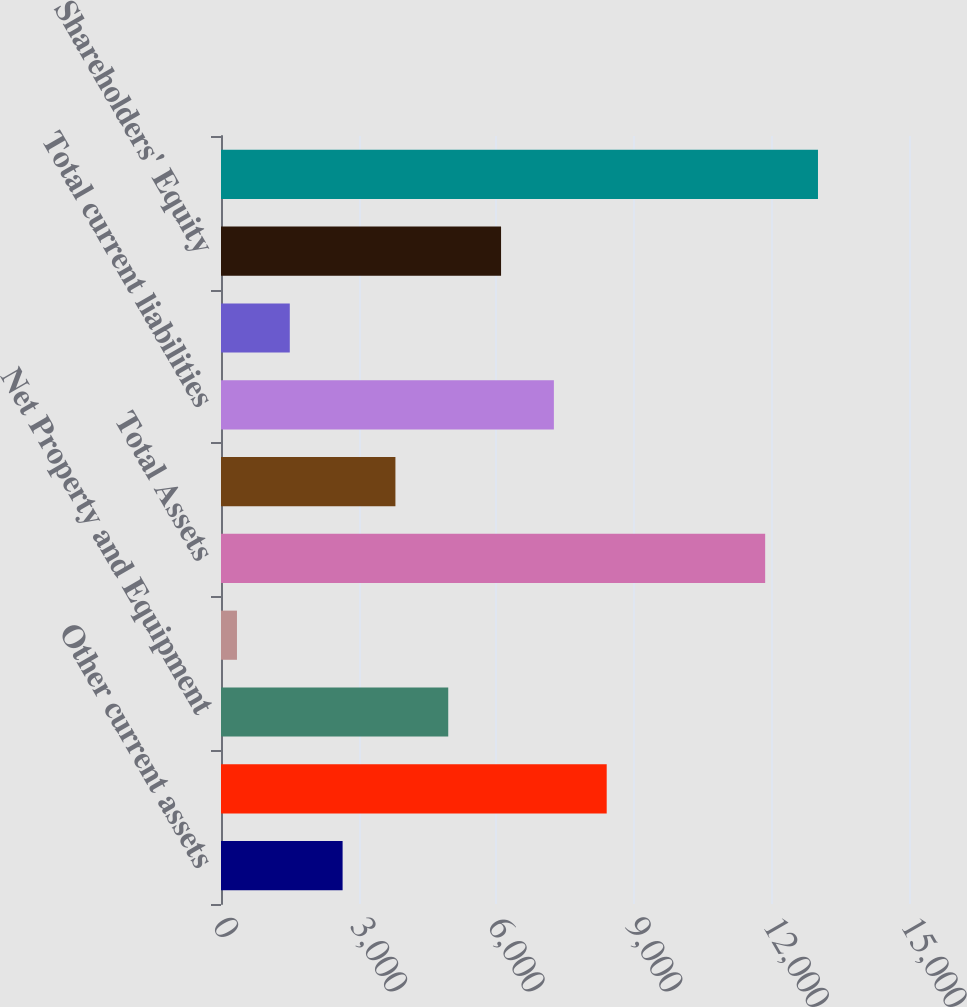Convert chart. <chart><loc_0><loc_0><loc_500><loc_500><bar_chart><fcel>Other current assets<fcel>Total current assets<fcel>Net Property and Equipment<fcel>Other Assets<fcel>Total Assets<fcel>Accrued liabilities<fcel>Total current liabilities<fcel>Long-Term Liabilities<fcel>Shareholders' Equity<fcel>Total Liabilities and<nl><fcel>2651.2<fcel>8409.2<fcel>4954.4<fcel>348<fcel>11864<fcel>3802.8<fcel>7257.6<fcel>1499.6<fcel>6106<fcel>13015.6<nl></chart> 